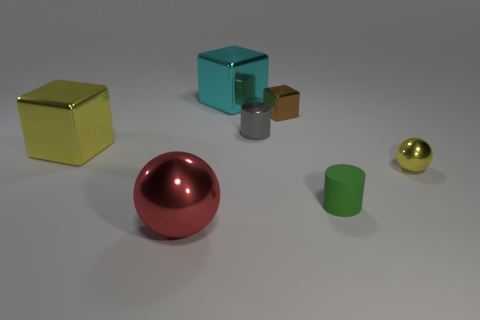Add 1 small brown objects. How many objects exist? 8 Subtract all blocks. How many objects are left? 4 Subtract all gray cylinders. Subtract all cyan shiny blocks. How many objects are left? 5 Add 2 tiny green matte cylinders. How many tiny green matte cylinders are left? 3 Add 6 tiny brown shiny objects. How many tiny brown shiny objects exist? 7 Subtract 0 yellow cylinders. How many objects are left? 7 